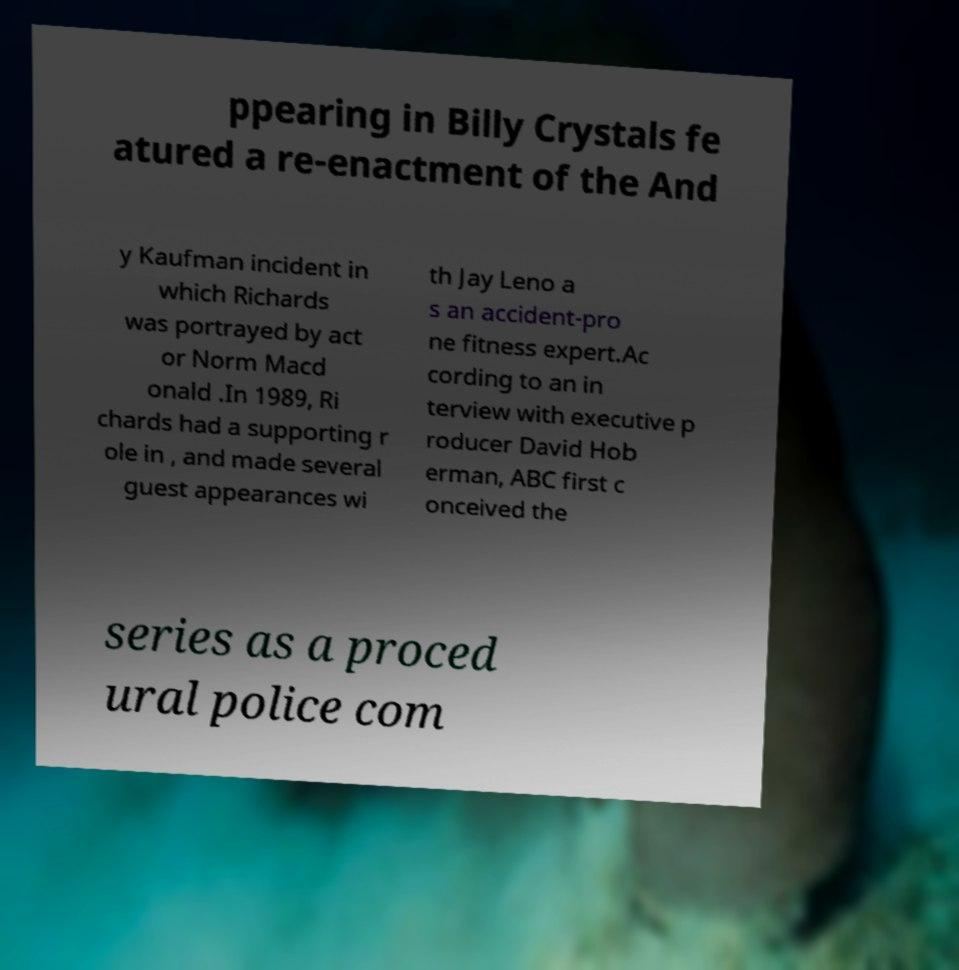I need the written content from this picture converted into text. Can you do that? ppearing in Billy Crystals fe atured a re-enactment of the And y Kaufman incident in which Richards was portrayed by act or Norm Macd onald .In 1989, Ri chards had a supporting r ole in , and made several guest appearances wi th Jay Leno a s an accident-pro ne fitness expert.Ac cording to an in terview with executive p roducer David Hob erman, ABC first c onceived the series as a proced ural police com 